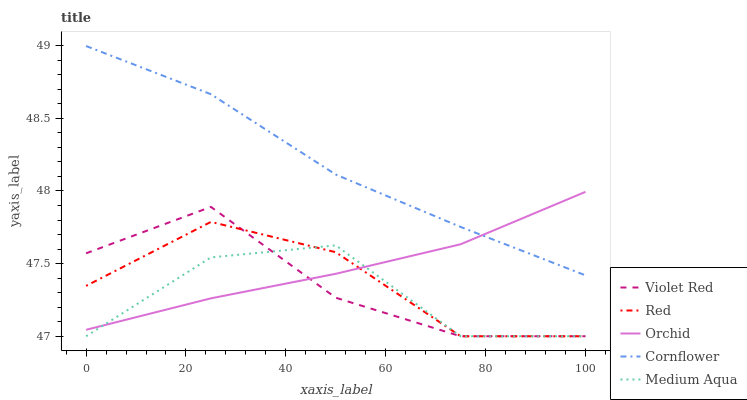Does Medium Aqua have the minimum area under the curve?
Answer yes or no. Yes. Does Cornflower have the maximum area under the curve?
Answer yes or no. Yes. Does Violet Red have the minimum area under the curve?
Answer yes or no. No. Does Violet Red have the maximum area under the curve?
Answer yes or no. No. Is Orchid the smoothest?
Answer yes or no. Yes. Is Medium Aqua the roughest?
Answer yes or no. Yes. Is Violet Red the smoothest?
Answer yes or no. No. Is Violet Red the roughest?
Answer yes or no. No. Does Violet Red have the lowest value?
Answer yes or no. Yes. Does Orchid have the lowest value?
Answer yes or no. No. Does Cornflower have the highest value?
Answer yes or no. Yes. Does Violet Red have the highest value?
Answer yes or no. No. Is Red less than Cornflower?
Answer yes or no. Yes. Is Cornflower greater than Medium Aqua?
Answer yes or no. Yes. Does Violet Red intersect Red?
Answer yes or no. Yes. Is Violet Red less than Red?
Answer yes or no. No. Is Violet Red greater than Red?
Answer yes or no. No. Does Red intersect Cornflower?
Answer yes or no. No. 